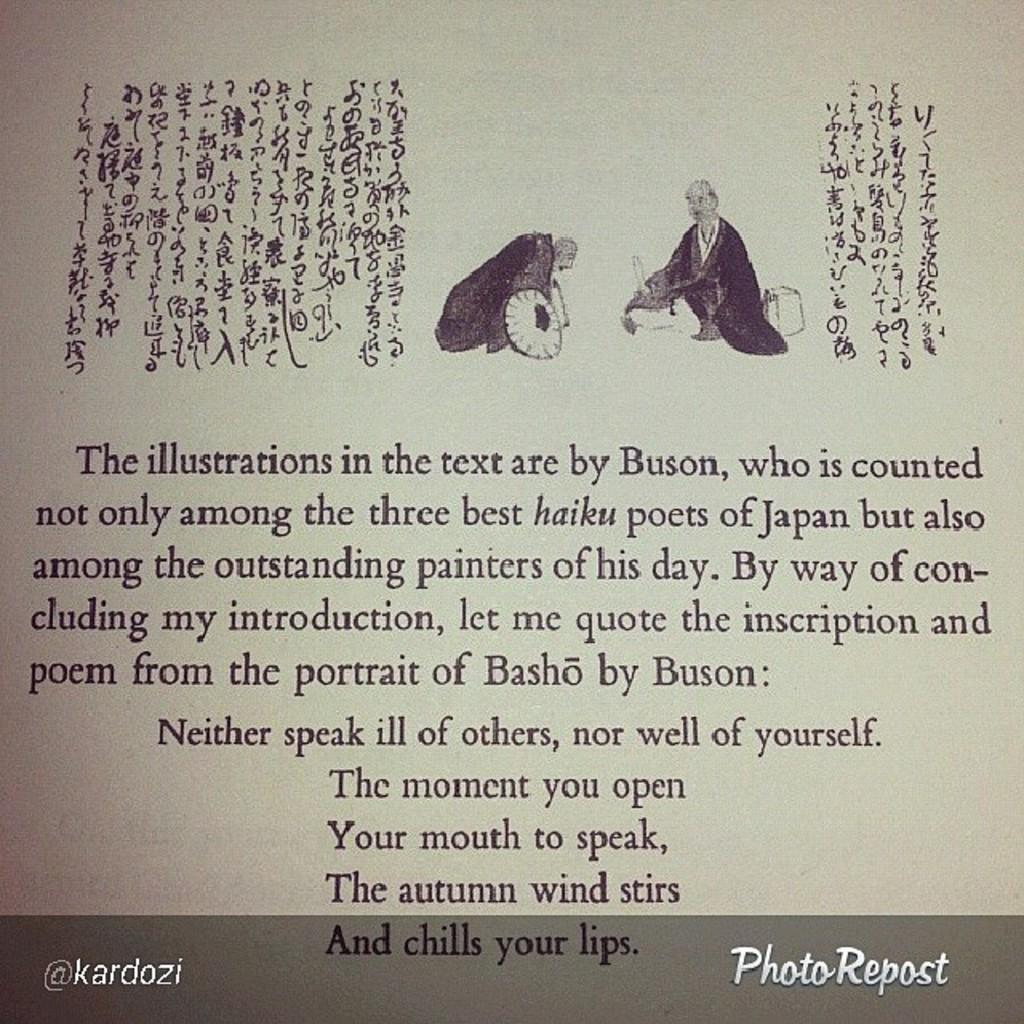<image>
Summarize the visual content of the image. an old asian picture that says the illustrations in the text are by Buson 